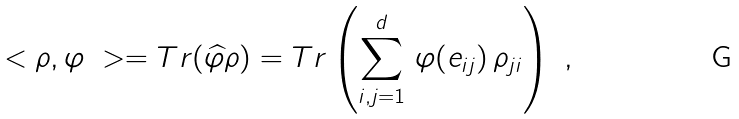<formula> <loc_0><loc_0><loc_500><loc_500>\ < \rho , \varphi \ > = T r ( \widehat { \varphi } \rho ) = T r \left ( \sum _ { i , j = 1 } ^ { d } \, \varphi ( e _ { i j } ) \, \rho _ { j i } \right ) \ ,</formula> 